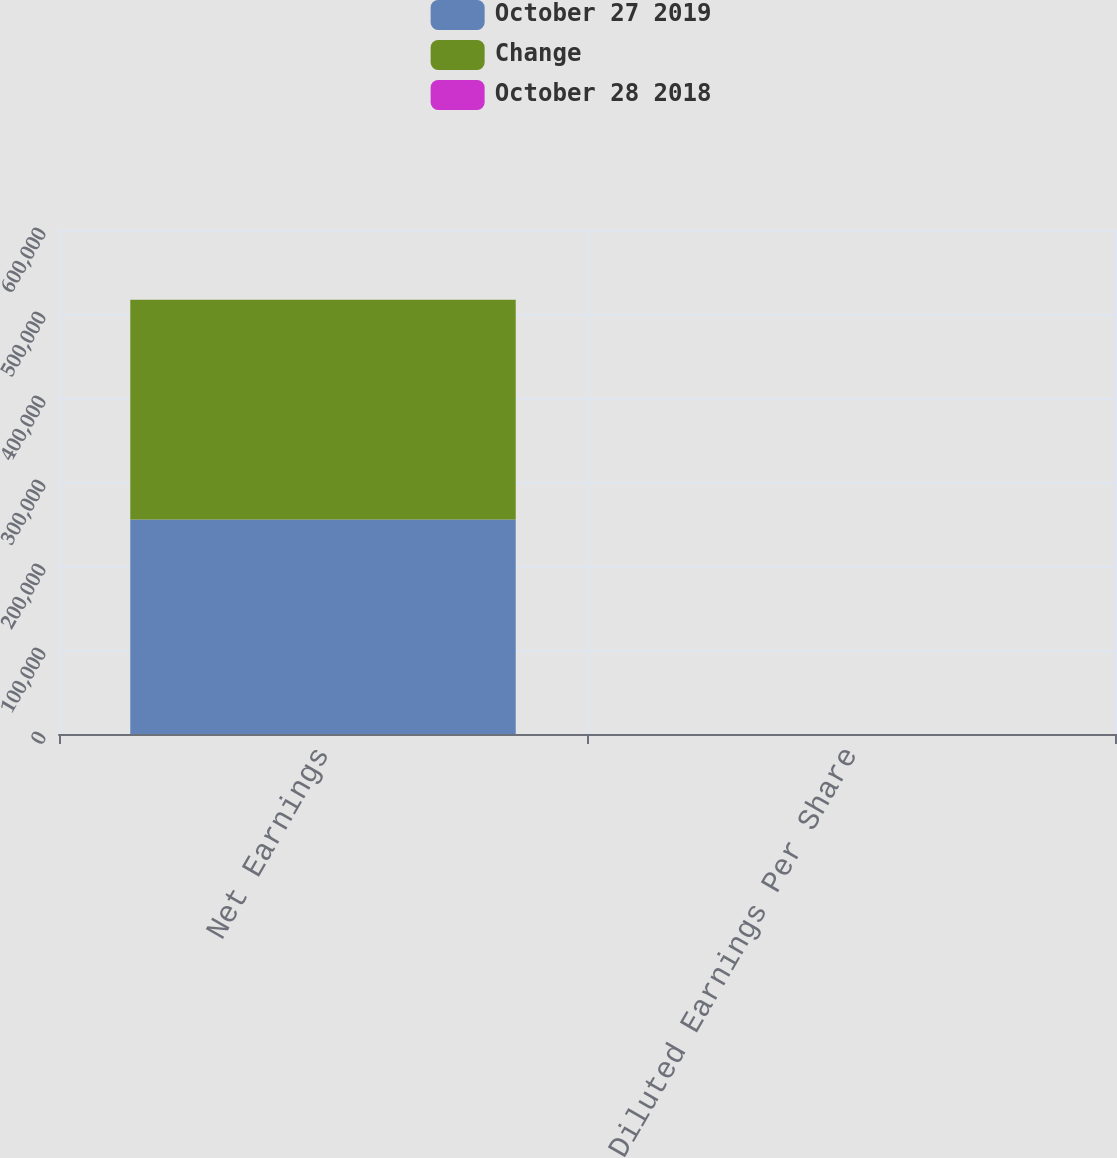<chart> <loc_0><loc_0><loc_500><loc_500><stacked_bar_chart><ecel><fcel>Net Earnings<fcel>Diluted Earnings Per Share<nl><fcel>October 27 2019<fcel>255503<fcel>0.47<nl><fcel>Change<fcel>261406<fcel>0.48<nl><fcel>October 28 2018<fcel>2.3<fcel>2.1<nl></chart> 